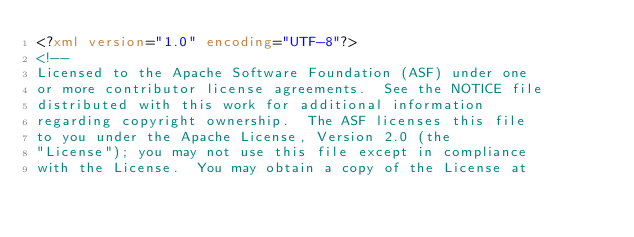<code> <loc_0><loc_0><loc_500><loc_500><_XML_><?xml version="1.0" encoding="UTF-8"?>
<!--
Licensed to the Apache Software Foundation (ASF) under one
or more contributor license agreements.  See the NOTICE file
distributed with this work for additional information
regarding copyright ownership.  The ASF licenses this file
to you under the Apache License, Version 2.0 (the
"License"); you may not use this file except in compliance
with the License.  You may obtain a copy of the License at</code> 